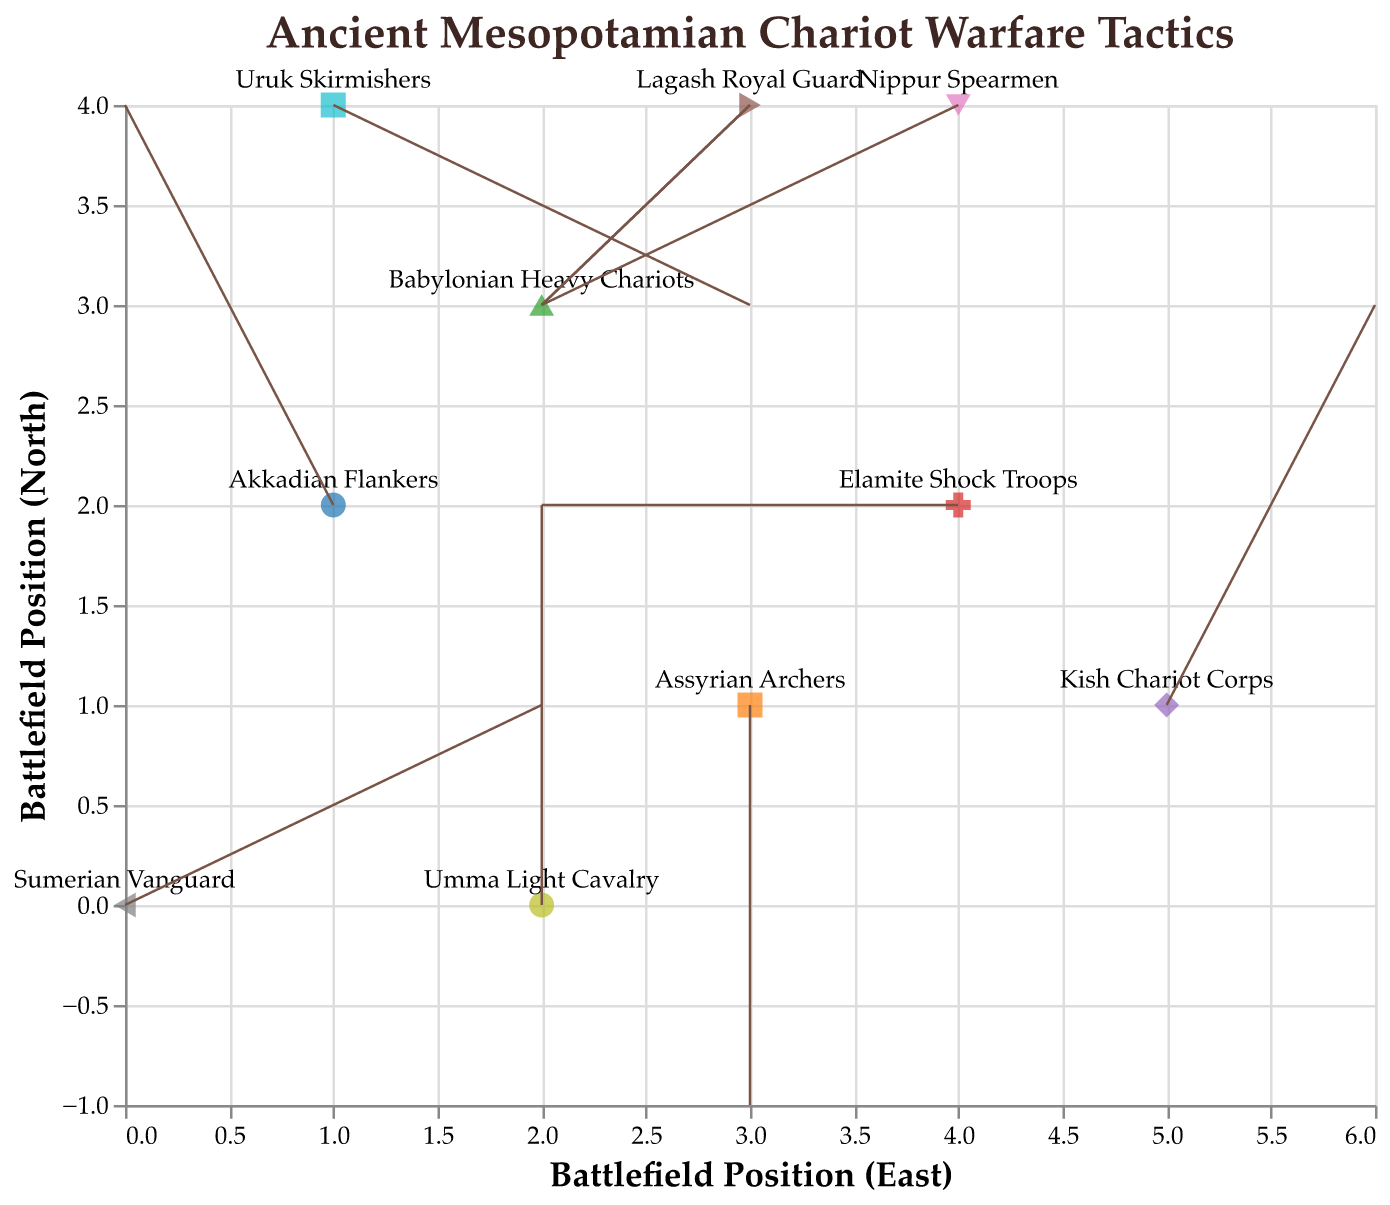Where is the Sumerian Vanguard unit located on the battlefield? The figure shows the Sumerian Vanguard unit at position (0, 0).
Answer: (0, 0) Which unit is positioned at (4, 2) and what are their movement vectors? The Elamite Shock Troops are located at (4, 2), and their movement vectors are (-2, 0).
Answer: Elamite Shock Troops, (-2, 0) What direction does the Umma Light Cavalry move? The Umma Light Cavalry is positioned at (2, 0) and moves northward with a vector (0, 2).
Answer: Northward How do the movements of the Akkadian Flankers and the Uruk Skirmishers differ? The Akkadian Flankers, located at (1, 2), move left and up with a vector (-1, 2). The Uruk Skirmishers, located at (1, 4), move right and down with a vector (2, -1).
Answer: Akkadian Flankers move left and up; Uruk Skirmishers move right and down Which units experience no vertical movement? The Elamite Shock Troops and the Umma Light Cavalry have vertical movement vectors of 0.
Answer: Elamite Shock Troops, Umma Light Cavalry Identify the unit that moves directly south and its initial and final positions. The Assyrian Archers, located at (3, 1), move south by 2 units, resulting in a final position (3, -1).
Answer: Assyrian Archers, (3, 1), (3, -1) What is the combined horizontal movement vector of the Nippur Spearmen and the Babylonian Heavy Chariots? Nippur Spearmen have a horizontal vector of -2, and Babylonian Heavy Chariots have a horizontal vector of 1. Summing these vectors: -2 + 1 = -1.
Answer: -1 Compare the initial positions of the Kish Chariot Corps and the Lagash Royal Guard and determine which one starts further south. The Kish Chariot Corps is located at (5, 1) and the Lagash Royal Guard at (3, 4). Since y=1 is less than y=4, the Kish Chariot Corps starts further south.
Answer: Kish Chariot Corps How many units start at a y-position of 4, and what are their names? The Uruk Skirmishers and the Lagash Royal Guard both start at y=4.
Answer: 2, Uruk Skirmishers, Lagash Royal Guard 